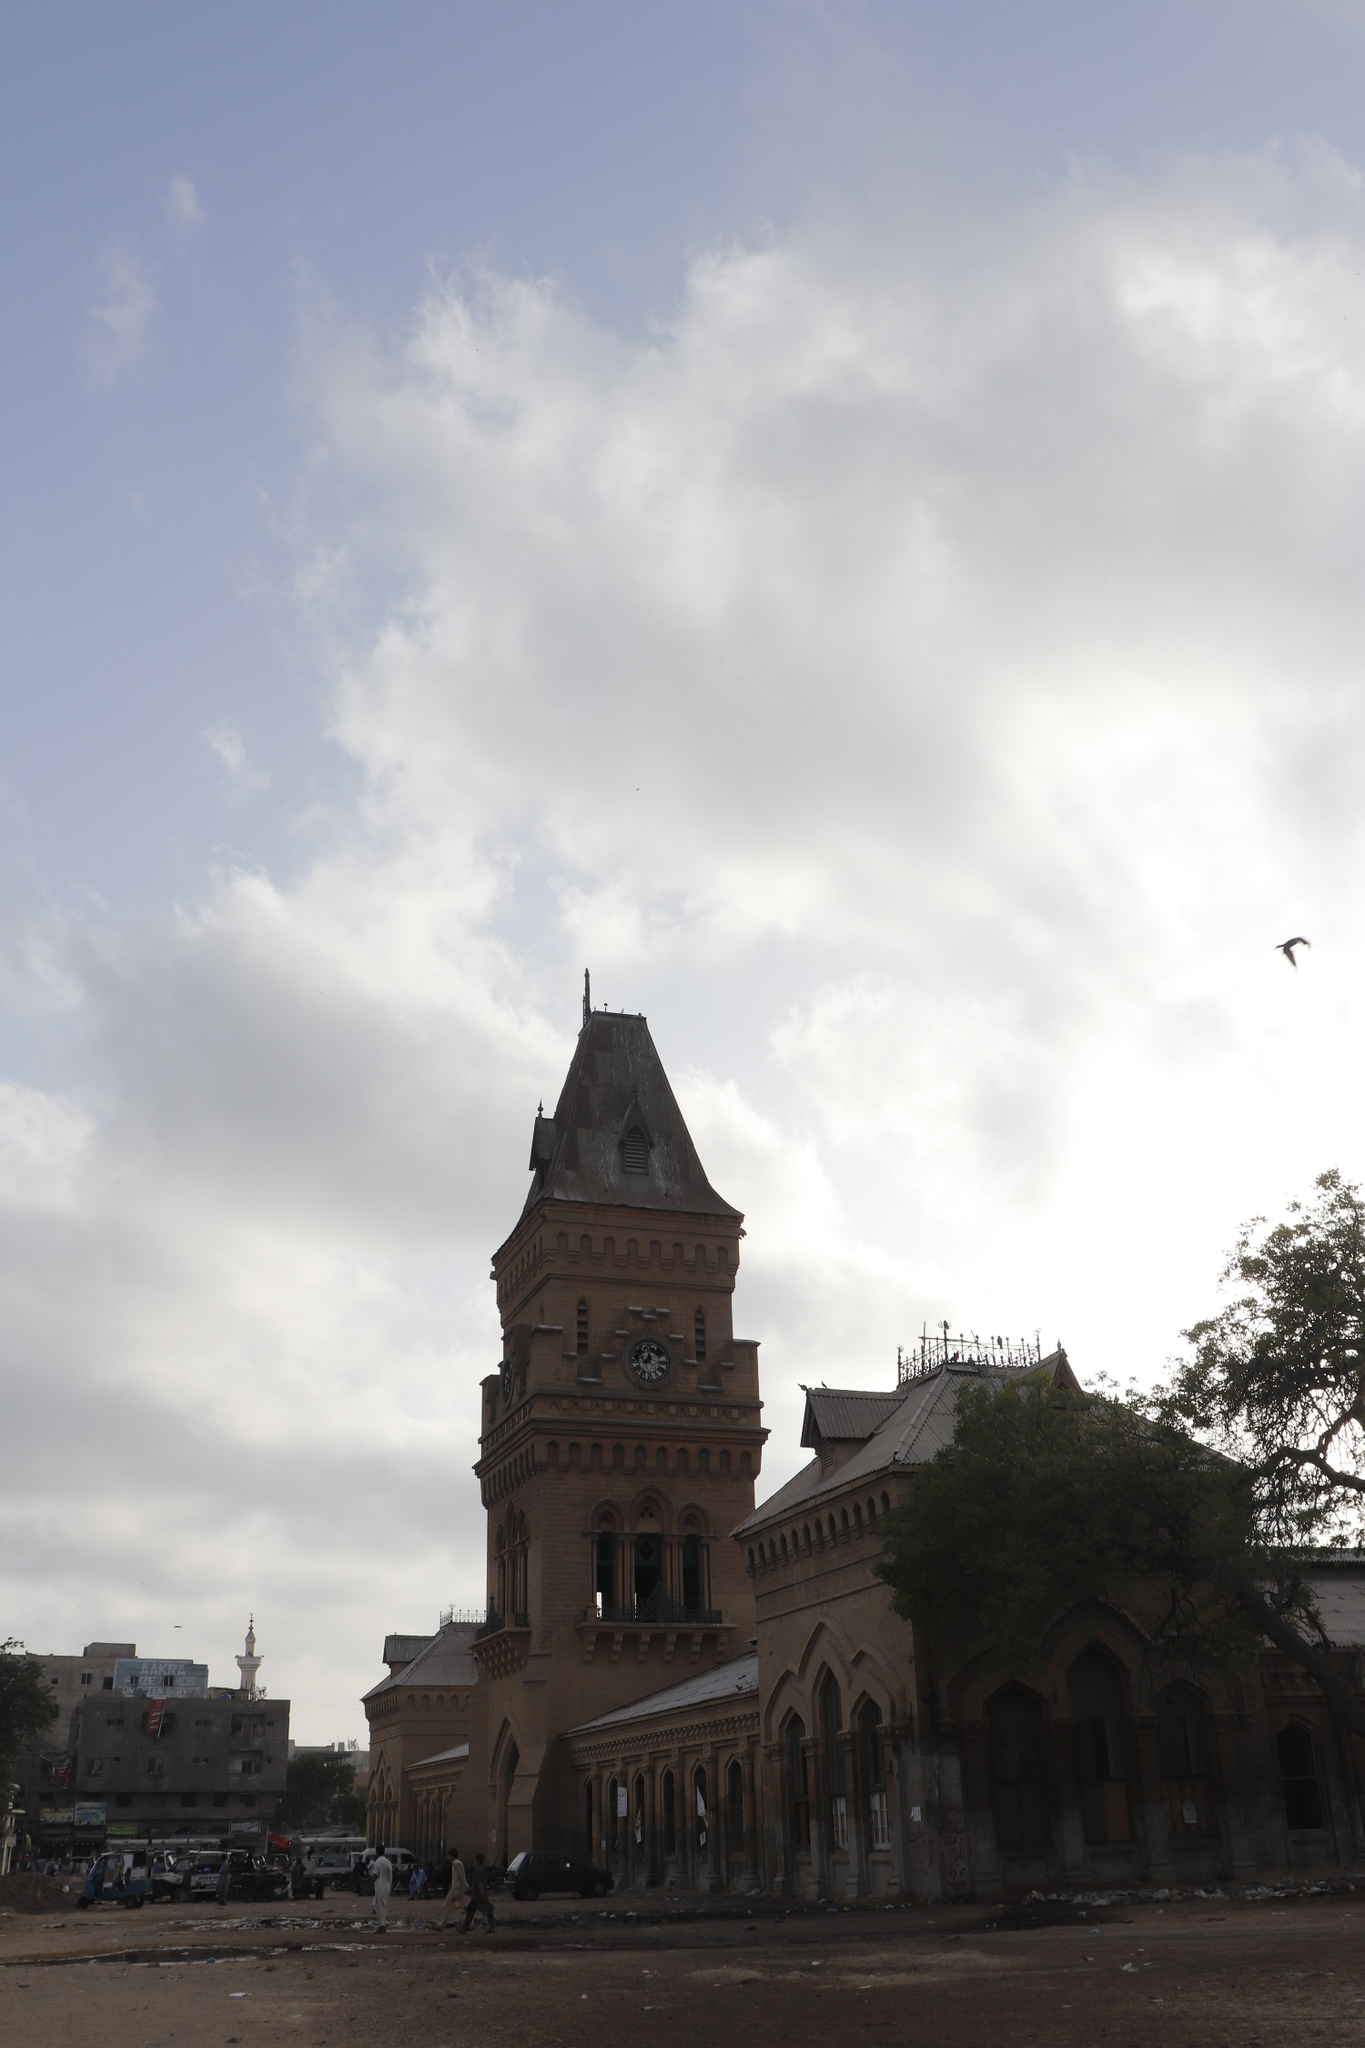Imagine you are a bird flying over the Empress Market. Describe your experience. As I soar above the Empress Market, the grand clock tower is the first feature that catches my eye, standing tall against the backdrop of a dynamic sky. The intricate details of the architecture are even more magnificent from this height, the arches, and the pointed roof, all merging into the bustling life below. I can see the vibrancy of the market with people moving in and out, carrying various goods. The trees and nearby buildings form a mosaic of shapes and shadows that blend into the historical fabric of the market. The view from above reveals a lively scene, a blend of history and contemporary life, that is both fascinating and humbling. 